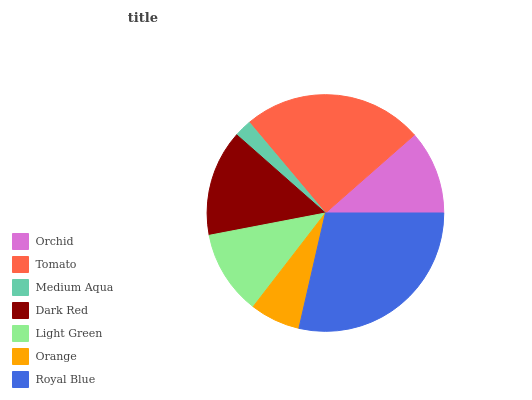Is Medium Aqua the minimum?
Answer yes or no. Yes. Is Royal Blue the maximum?
Answer yes or no. Yes. Is Tomato the minimum?
Answer yes or no. No. Is Tomato the maximum?
Answer yes or no. No. Is Tomato greater than Orchid?
Answer yes or no. Yes. Is Orchid less than Tomato?
Answer yes or no. Yes. Is Orchid greater than Tomato?
Answer yes or no. No. Is Tomato less than Orchid?
Answer yes or no. No. Is Light Green the high median?
Answer yes or no. Yes. Is Light Green the low median?
Answer yes or no. Yes. Is Medium Aqua the high median?
Answer yes or no. No. Is Dark Red the low median?
Answer yes or no. No. 